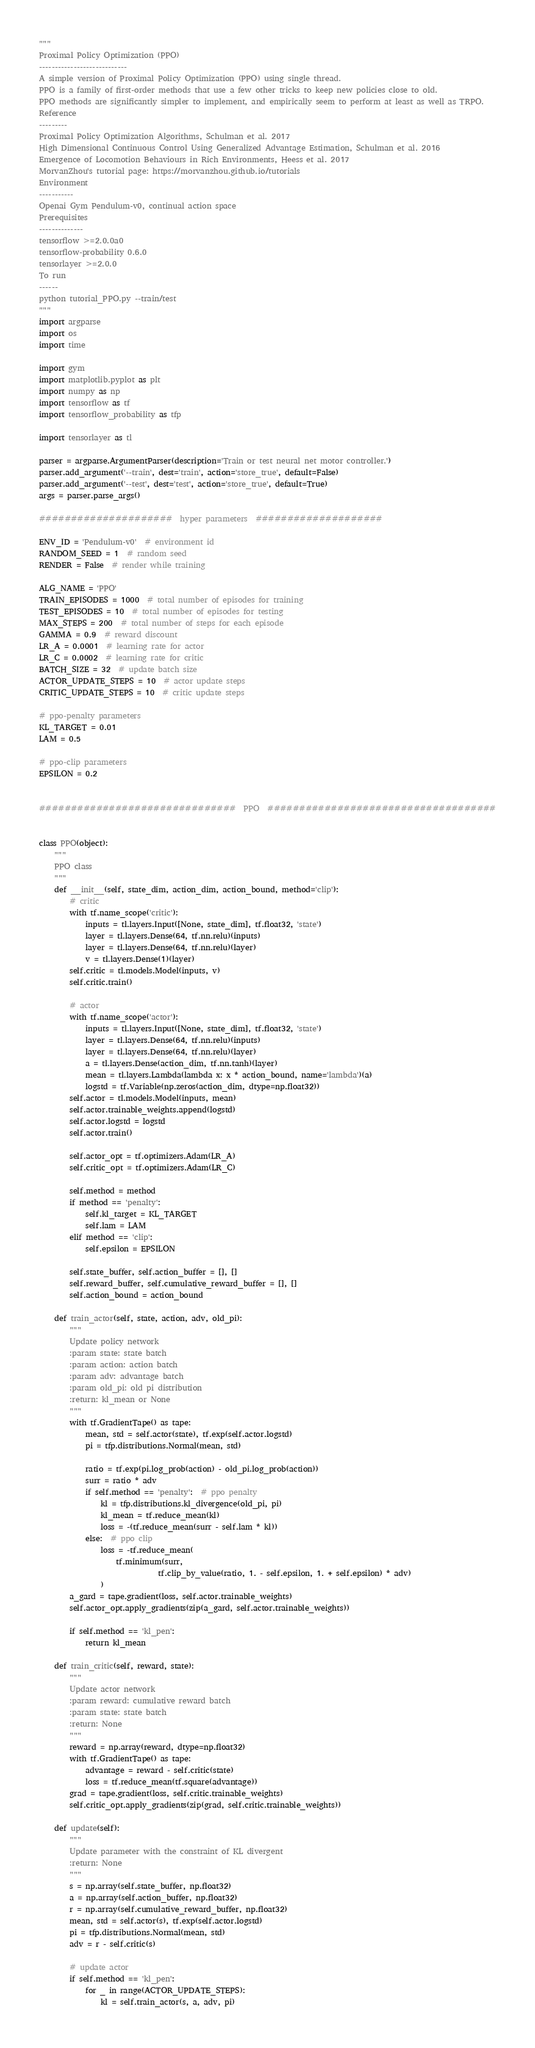Convert code to text. <code><loc_0><loc_0><loc_500><loc_500><_Python_>"""
Proximal Policy Optimization (PPO)
----------------------------
A simple version of Proximal Policy Optimization (PPO) using single thread.
PPO is a family of first-order methods that use a few other tricks to keep new policies close to old.
PPO methods are significantly simpler to implement, and empirically seem to perform at least as well as TRPO.
Reference
---------
Proximal Policy Optimization Algorithms, Schulman et al. 2017
High Dimensional Continuous Control Using Generalized Advantage Estimation, Schulman et al. 2016
Emergence of Locomotion Behaviours in Rich Environments, Heess et al. 2017
MorvanZhou's tutorial page: https://morvanzhou.github.io/tutorials
Environment
-----------
Openai Gym Pendulum-v0, continual action space
Prerequisites
--------------
tensorflow >=2.0.0a0
tensorflow-probability 0.6.0
tensorlayer >=2.0.0
To run
------
python tutorial_PPO.py --train/test
"""
import argparse
import os
import time

import gym
import matplotlib.pyplot as plt
import numpy as np
import tensorflow as tf
import tensorflow_probability as tfp

import tensorlayer as tl

parser = argparse.ArgumentParser(description='Train or test neural net motor controller.')
parser.add_argument('--train', dest='train', action='store_true', default=False)
parser.add_argument('--test', dest='test', action='store_true', default=True)
args = parser.parse_args()

#####################  hyper parameters  ####################

ENV_ID = 'Pendulum-v0'  # environment id
RANDOM_SEED = 1  # random seed
RENDER = False  # render while training

ALG_NAME = 'PPO'
TRAIN_EPISODES = 1000  # total number of episodes for training
TEST_EPISODES = 10  # total number of episodes for testing
MAX_STEPS = 200  # total number of steps for each episode
GAMMA = 0.9  # reward discount
LR_A = 0.0001  # learning rate for actor
LR_C = 0.0002  # learning rate for critic
BATCH_SIZE = 32  # update batch size
ACTOR_UPDATE_STEPS = 10  # actor update steps
CRITIC_UPDATE_STEPS = 10  # critic update steps

# ppo-penalty parameters
KL_TARGET = 0.01
LAM = 0.5

# ppo-clip parameters
EPSILON = 0.2


###############################  PPO  ####################################


class PPO(object):
    """
    PPO class
    """
    def __init__(self, state_dim, action_dim, action_bound, method='clip'):
        # critic
        with tf.name_scope('critic'):
            inputs = tl.layers.Input([None, state_dim], tf.float32, 'state')
            layer = tl.layers.Dense(64, tf.nn.relu)(inputs)
            layer = tl.layers.Dense(64, tf.nn.relu)(layer)
            v = tl.layers.Dense(1)(layer)
        self.critic = tl.models.Model(inputs, v)
        self.critic.train()

        # actor
        with tf.name_scope('actor'):
            inputs = tl.layers.Input([None, state_dim], tf.float32, 'state')
            layer = tl.layers.Dense(64, tf.nn.relu)(inputs)
            layer = tl.layers.Dense(64, tf.nn.relu)(layer)
            a = tl.layers.Dense(action_dim, tf.nn.tanh)(layer)
            mean = tl.layers.Lambda(lambda x: x * action_bound, name='lambda')(a)
            logstd = tf.Variable(np.zeros(action_dim, dtype=np.float32))
        self.actor = tl.models.Model(inputs, mean)
        self.actor.trainable_weights.append(logstd)
        self.actor.logstd = logstd
        self.actor.train()

        self.actor_opt = tf.optimizers.Adam(LR_A)
        self.critic_opt = tf.optimizers.Adam(LR_C)

        self.method = method
        if method == 'penalty':
            self.kl_target = KL_TARGET
            self.lam = LAM
        elif method == 'clip':
            self.epsilon = EPSILON

        self.state_buffer, self.action_buffer = [], []
        self.reward_buffer, self.cumulative_reward_buffer = [], []
        self.action_bound = action_bound

    def train_actor(self, state, action, adv, old_pi):
        """
        Update policy network
        :param state: state batch
        :param action: action batch
        :param adv: advantage batch
        :param old_pi: old pi distribution
        :return: kl_mean or None
        """
        with tf.GradientTape() as tape:
            mean, std = self.actor(state), tf.exp(self.actor.logstd)
            pi = tfp.distributions.Normal(mean, std)

            ratio = tf.exp(pi.log_prob(action) - old_pi.log_prob(action))
            surr = ratio * adv
            if self.method == 'penalty':  # ppo penalty
                kl = tfp.distributions.kl_divergence(old_pi, pi)
                kl_mean = tf.reduce_mean(kl)
                loss = -(tf.reduce_mean(surr - self.lam * kl))
            else:  # ppo clip
                loss = -tf.reduce_mean(
                    tf.minimum(surr,
                               tf.clip_by_value(ratio, 1. - self.epsilon, 1. + self.epsilon) * adv)
                )
        a_gard = tape.gradient(loss, self.actor.trainable_weights)
        self.actor_opt.apply_gradients(zip(a_gard, self.actor.trainable_weights))

        if self.method == 'kl_pen':
            return kl_mean

    def train_critic(self, reward, state):
        """
        Update actor network
        :param reward: cumulative reward batch
        :param state: state batch
        :return: None
        """
        reward = np.array(reward, dtype=np.float32)
        with tf.GradientTape() as tape:
            advantage = reward - self.critic(state)
            loss = tf.reduce_mean(tf.square(advantage))
        grad = tape.gradient(loss, self.critic.trainable_weights)
        self.critic_opt.apply_gradients(zip(grad, self.critic.trainable_weights))

    def update(self):
        """
        Update parameter with the constraint of KL divergent
        :return: None
        """
        s = np.array(self.state_buffer, np.float32)
        a = np.array(self.action_buffer, np.float32)
        r = np.array(self.cumulative_reward_buffer, np.float32)
        mean, std = self.actor(s), tf.exp(self.actor.logstd)
        pi = tfp.distributions.Normal(mean, std)
        adv = r - self.critic(s)

        # update actor
        if self.method == 'kl_pen':
            for _ in range(ACTOR_UPDATE_STEPS):
                kl = self.train_actor(s, a, adv, pi)</code> 